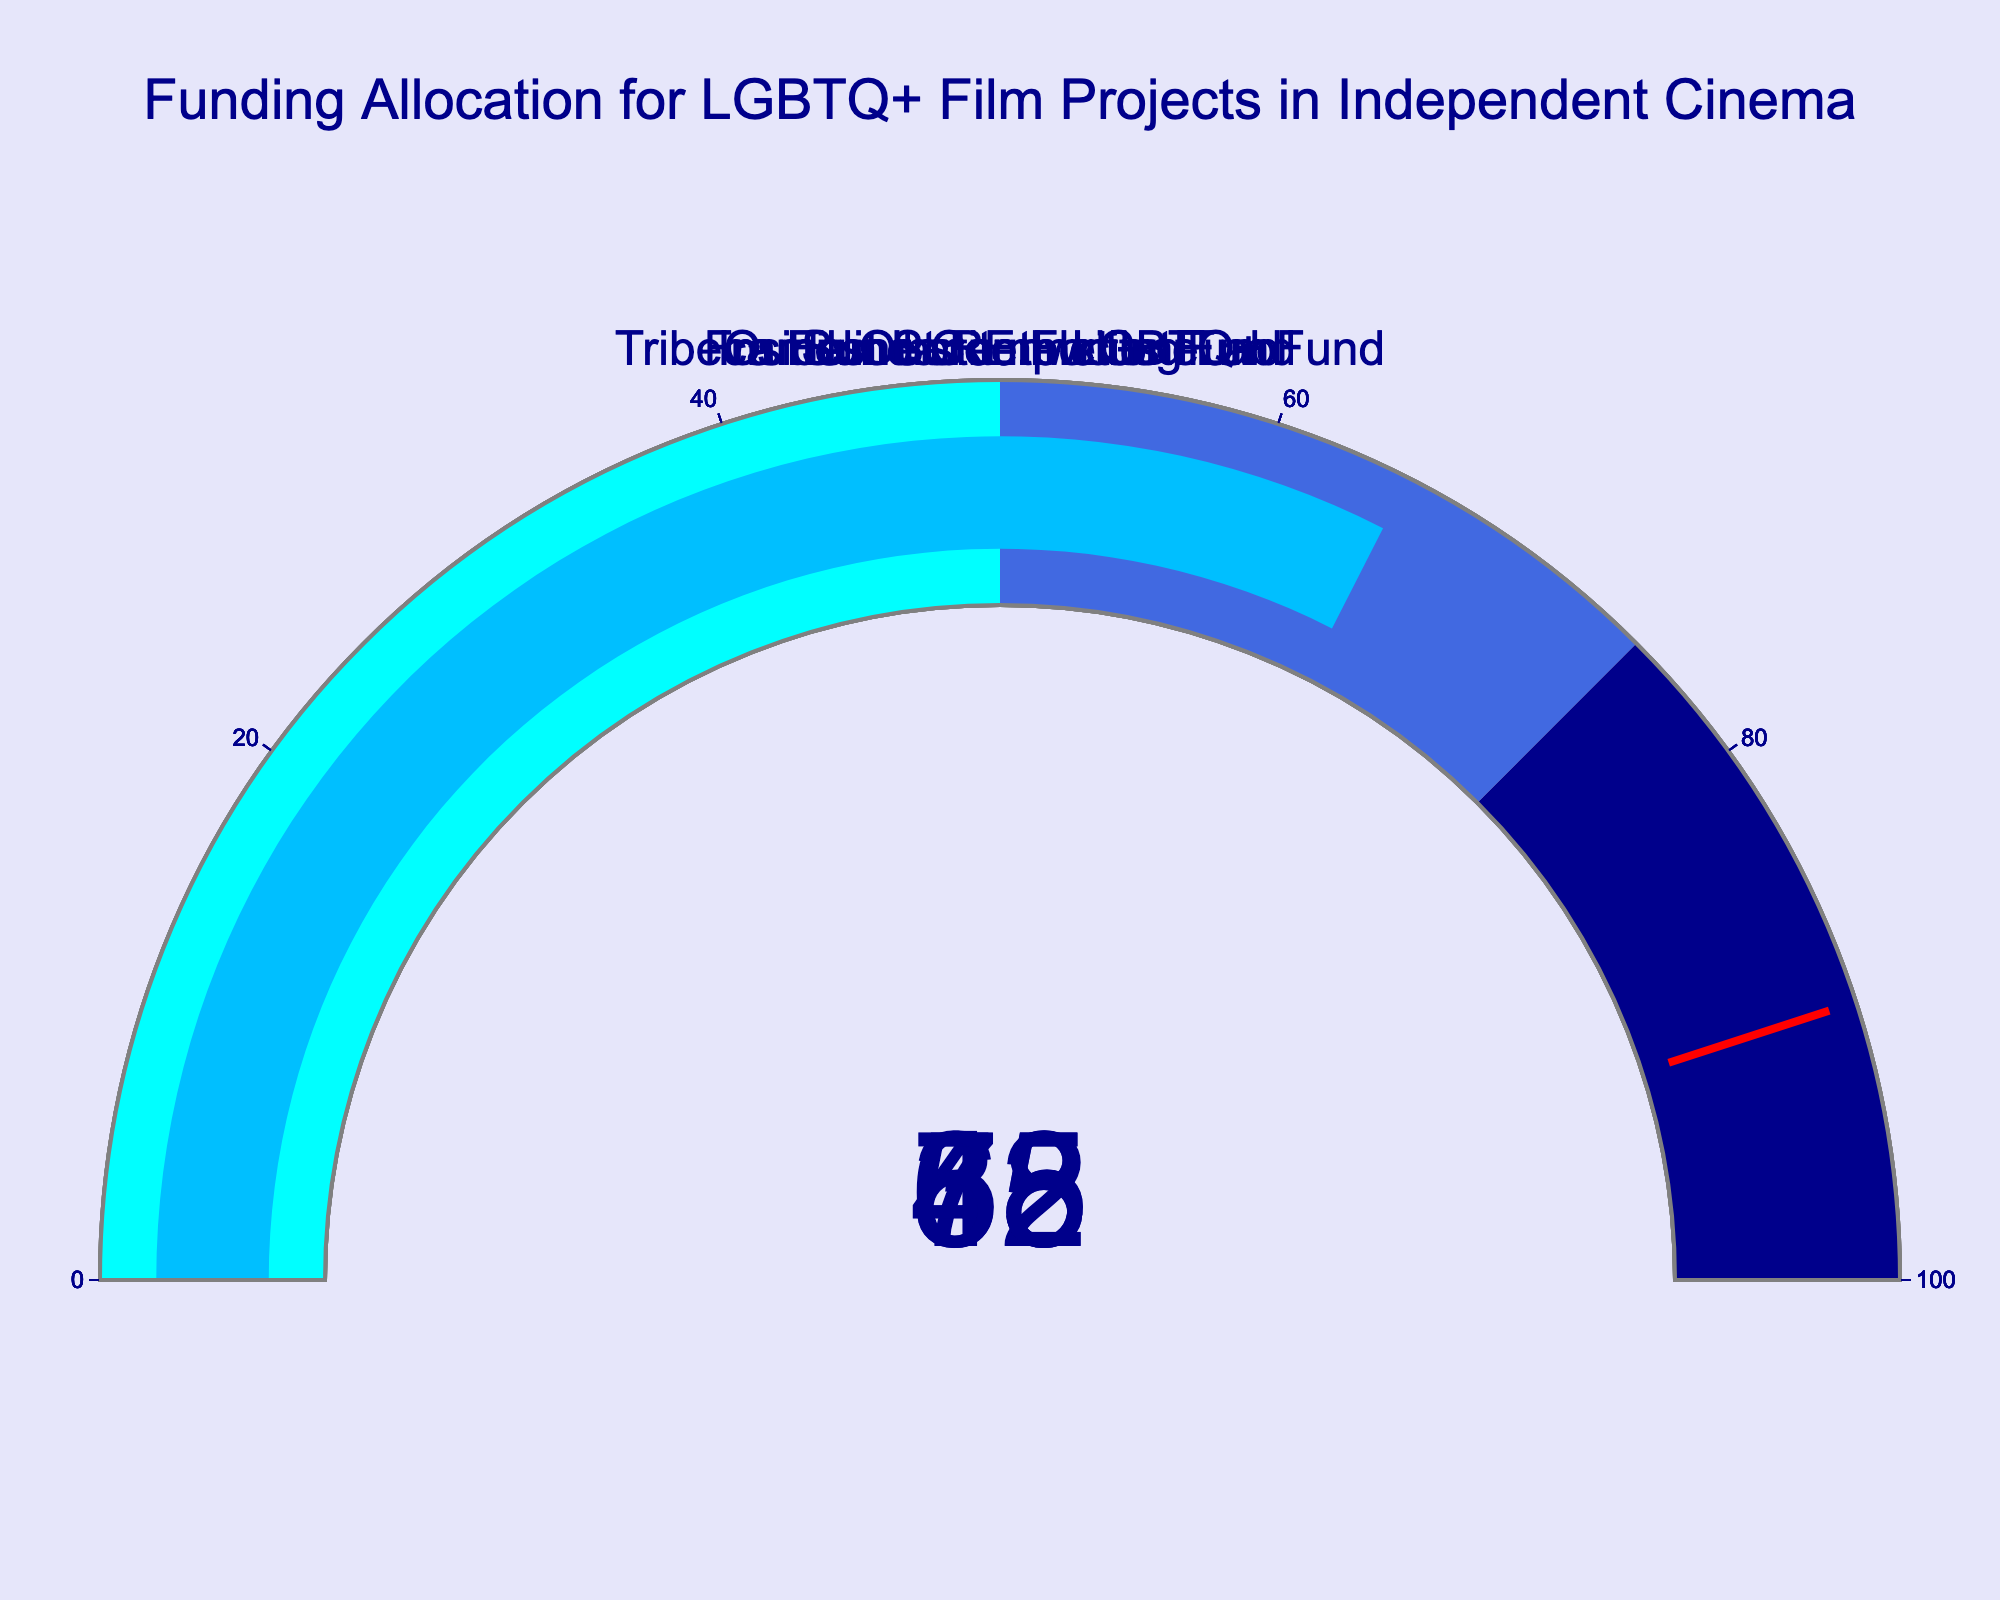What is the percentage allocated by the Sundance Institute? The gauge for the Sundance Institute shows a value of 72.
Answer: 72 How many funding categories are represented in the figure? The figure contains gauges for Sundance Institute, Frameline Completion Fund, Outfest Screenwriting Lab, Inside Out RE:Focus Fund, and Tribeca Film Institute LGBTQ+ Fund, totaling 5 categories.
Answer: 5 Which funding category has the lowest percentage allocation? By evaluating all the gauges, the Outfest Screenwriting Lab has the lowest percentage at 38.
Answer: Outfest Screenwriting Lab What is the combined percentage allocation for the Inside Out RE:Focus Fund and Tribeca Film Institute LGBTQ+ Fund? The Inside Out RE:Focus Fund has 58, and the Tribeca Film Institute LGBTQ+ Fund has 65. Adding these together results in 58 + 65 = 123.
Answer: 123 How much higher is the percentage allocation of the Sundance Institute compared to the Frameline Completion Fund? The difference is calculated by subtracting the Frameline Completion Fund (45) from the Sundance Institute (72). 72 - 45 = 27.
Answer: 27 What is the average funding percentage of all the categories shown? Adding all the values (72, 45, 38, 58, 65) gives 278. Divide by 5 categories, so 278 / 5 = 55.6.
Answer: 55.6 Which two categories have percentage allocations in the 50-75 range? The two gauges that fall within the 50-75 range are Inside Out RE:Focus Fund (58) and Tribeca Film Institute LGBTQ+ Fund (65).
Answer: Inside Out RE:Focus Fund and Tribeca Film Institute LGBTQ+ Fund Is any category’s funding percentage close to the threshold indicator shown at 90? None of the gauges in the figure show values close to the threshold value of 90. The highest gauge shows 72.
Answer: No What is the difference in funding allocation between the highest and the lowest categories? The highest allocation is Sundance Institute at 72, and the lowest is Outfest Screenwriting Lab at 38. The difference is 72 - 38 = 34.
Answer: 34 